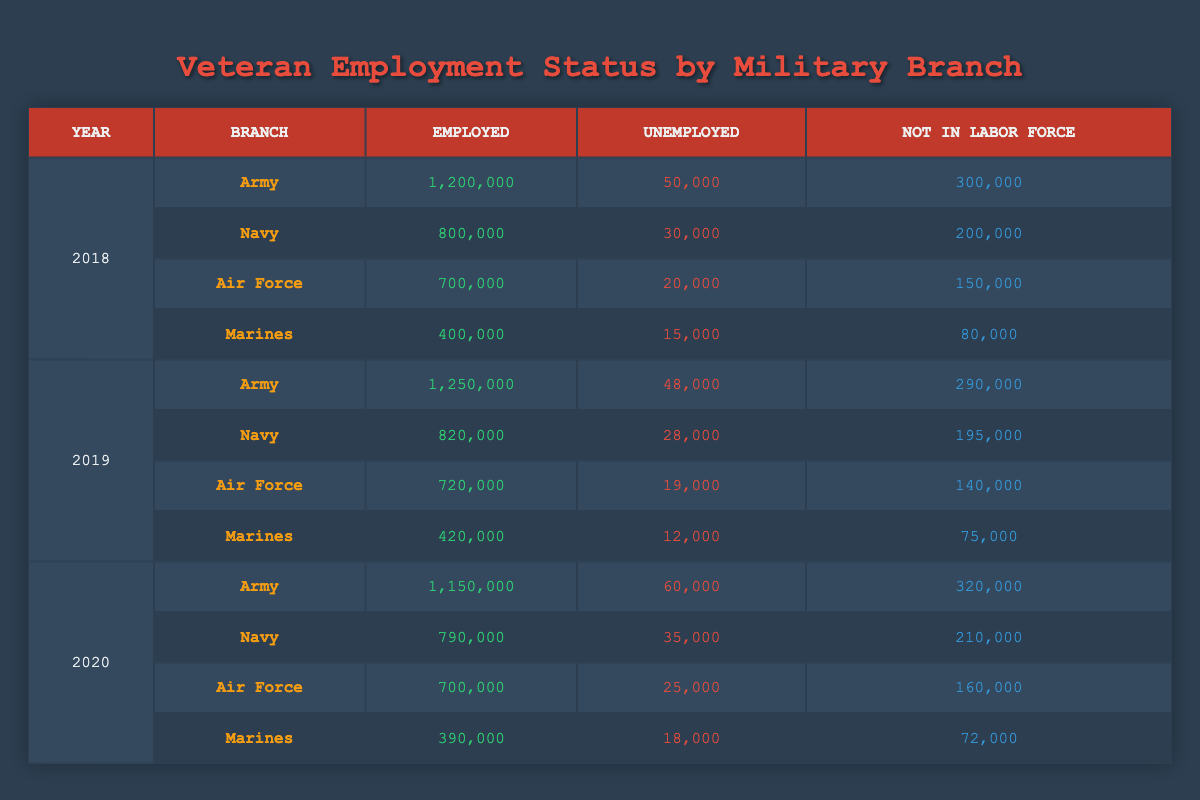What was the total number of unemployed veterans in the Army in 2019? In 2019, the table shows that the Army had 48,000 unemployed veterans. Therefore, the total number of unemployed veterans in the Army for that year is simply 48,000.
Answer: 48,000 Which military branch had the highest number of employed veterans in 2020? According to the table for 2020, the Army had 1,150,000 employed veterans, more than any other branch. The Navy had 790,000, the Air Force had 700,000, and the Marines had 390,000. Thus, the Army has the highest number.
Answer: Army What was the change in the number of employed veterans in the Navy from 2018 to 2020? In 2018, the Navy had 800,000 employed veterans, and in 2020, it had 790,000. The change is calculated as 790,000 - 800,000, which results in a decrease of 10,000.
Answer: Decrease of 10,000 In 2018, what percentage of the total veterans from the Air Force were unemployed? For the Air Force in 2018, there were 700,000 employed and 20,000 unemployed veterans, which gives a total of 700,000 + 20,000 + 150,000 (not in labor force) = 870,000 veterans. The percentage of unemployed veterans is (20,000 / 870,000) * 100, which is approximately 2.30%.
Answer: Approximately 2.30% Did the number of unemployed veterans in the Marines decrease from 2018 to 2019? In 2018, the Marines had 15,000 unemployed veterans, and in 2019, this number dropped to 12,000. Since 12,000 is less than 15,000, it shows a decrease in the number of unemployed veterans.
Answer: Yes What is the total number of veterans not in the labor force across all branches in 2020? The numbers not in the labor force in 2020 are: Army (320,000) + Navy (210,000) + Air Force (160,000) + Marines (72,000). Adding these together: 320,000 + 210,000 + 160,000 + 72,000 = 762,000. This provides a total of 762,000 veterans not in the labor force across all branches.
Answer: 762,000 Which year had the highest unemployment rates among Air Force veterans? In the table, the Air Force had 20,000 unemployed in 2018, 19,000 in 2019, and 25,000 in 2020. The highest value is in 2020, indicating that this year had the most unemployed veterans in the Air Force.
Answer: 2020 What is the difference in the number of unemployed veterans between the Army and the Marines in 2019? In 2019, the Army had 48,000 unemployed veterans, and the Marines had 12,000. The difference is calculated as 48,000 - 12,000, giving us 36,000 more unemployed veterans in the Army compared to the Marines.
Answer: 36,000 How many veterans were employed in the Air Force in 2019? According to the table, the number of employed veterans in the Air Force for 2019 is stated as 720,000, which can be directly referenced from the data.
Answer: 720,000 